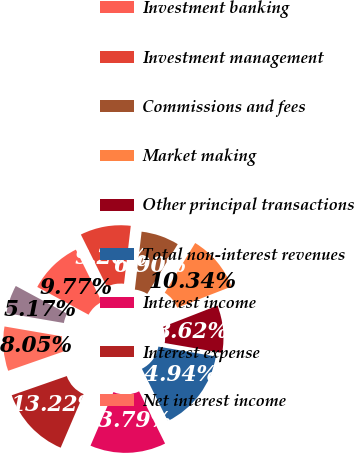Convert chart. <chart><loc_0><loc_0><loc_500><loc_500><pie_chart><fcel>in millions except per share<fcel>Investment banking<fcel>Investment management<fcel>Commissions and fees<fcel>Market making<fcel>Other principal transactions<fcel>Total non-interest revenues<fcel>Interest income<fcel>Interest expense<fcel>Net interest income<nl><fcel>5.17%<fcel>9.77%<fcel>9.2%<fcel>6.9%<fcel>10.34%<fcel>8.62%<fcel>14.94%<fcel>13.79%<fcel>13.22%<fcel>8.05%<nl></chart> 